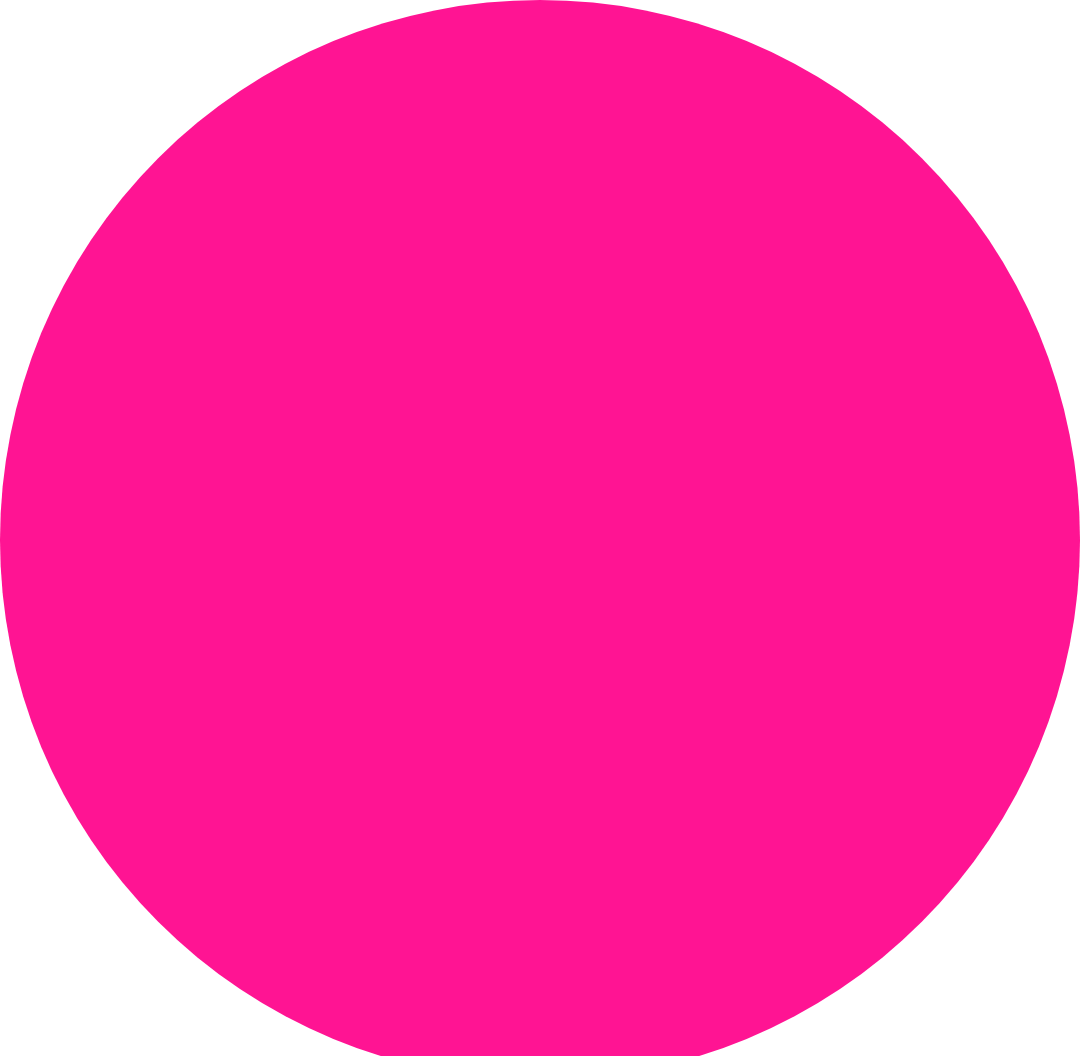<chart> <loc_0><loc_0><loc_500><loc_500><pie_chart><fcel>Balances as of December 31<nl><fcel>100.0%<nl></chart> 